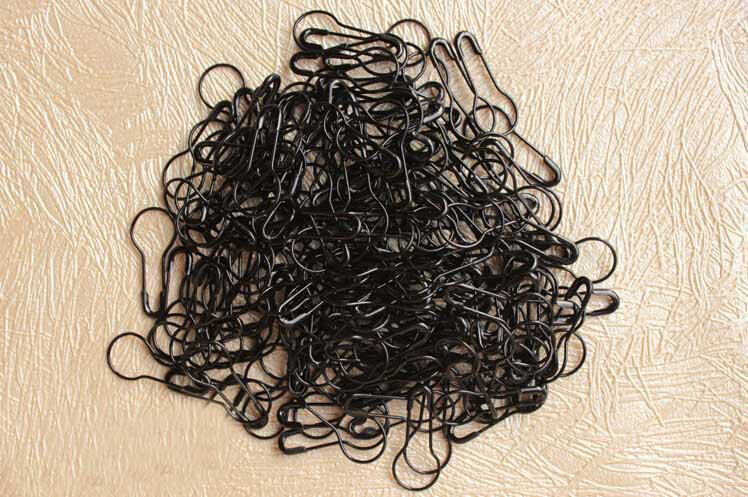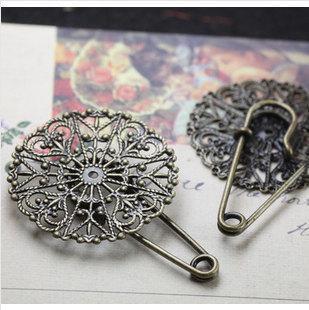The first image is the image on the left, the second image is the image on the right. Examine the images to the left and right. Is the description "An image shows only a pile of gold pins that are pear-shaped." accurate? Answer yes or no. No. 